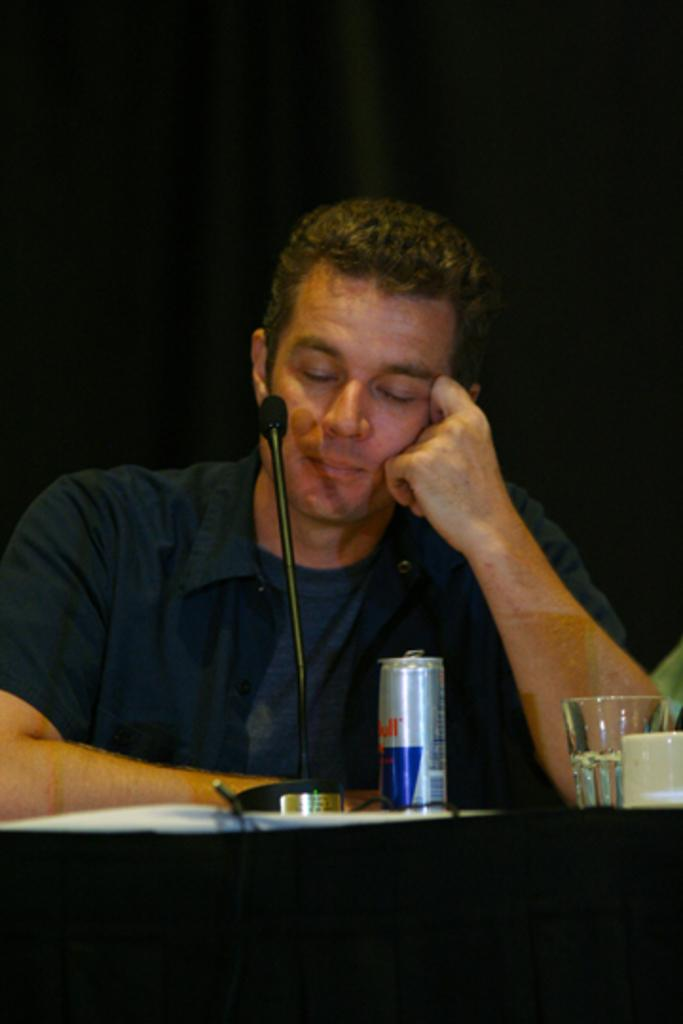What color is the shirt worn by the person in the image? The person is wearing a blue shirt. What is the person doing with their eyes in the image? The person is closing their eyes. What can be seen in front of the person? There is a red bull and a microphone (mike) in front of the person. What object is placed next to the microphone? There is a glass in front of the person. What is the color of the background in the image? The background of the image is black in color. What type of tin can be seen in the image? There is no tin present in the image. Are there any bells visible in the image? There are no bells visible in the image. 